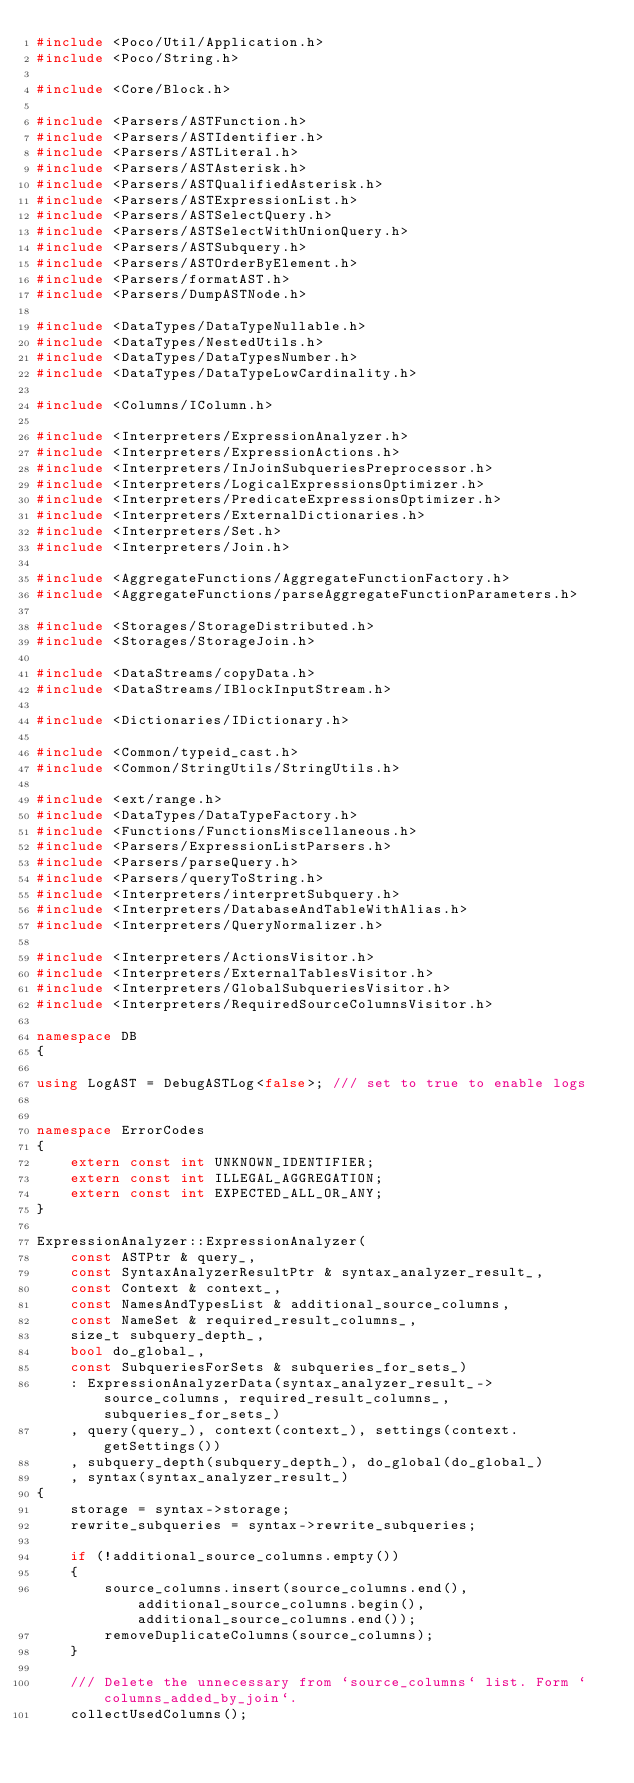<code> <loc_0><loc_0><loc_500><loc_500><_C++_>#include <Poco/Util/Application.h>
#include <Poco/String.h>

#include <Core/Block.h>

#include <Parsers/ASTFunction.h>
#include <Parsers/ASTIdentifier.h>
#include <Parsers/ASTLiteral.h>
#include <Parsers/ASTAsterisk.h>
#include <Parsers/ASTQualifiedAsterisk.h>
#include <Parsers/ASTExpressionList.h>
#include <Parsers/ASTSelectQuery.h>
#include <Parsers/ASTSelectWithUnionQuery.h>
#include <Parsers/ASTSubquery.h>
#include <Parsers/ASTOrderByElement.h>
#include <Parsers/formatAST.h>
#include <Parsers/DumpASTNode.h>

#include <DataTypes/DataTypeNullable.h>
#include <DataTypes/NestedUtils.h>
#include <DataTypes/DataTypesNumber.h>
#include <DataTypes/DataTypeLowCardinality.h>

#include <Columns/IColumn.h>

#include <Interpreters/ExpressionAnalyzer.h>
#include <Interpreters/ExpressionActions.h>
#include <Interpreters/InJoinSubqueriesPreprocessor.h>
#include <Interpreters/LogicalExpressionsOptimizer.h>
#include <Interpreters/PredicateExpressionsOptimizer.h>
#include <Interpreters/ExternalDictionaries.h>
#include <Interpreters/Set.h>
#include <Interpreters/Join.h>

#include <AggregateFunctions/AggregateFunctionFactory.h>
#include <AggregateFunctions/parseAggregateFunctionParameters.h>

#include <Storages/StorageDistributed.h>
#include <Storages/StorageJoin.h>

#include <DataStreams/copyData.h>
#include <DataStreams/IBlockInputStream.h>

#include <Dictionaries/IDictionary.h>

#include <Common/typeid_cast.h>
#include <Common/StringUtils/StringUtils.h>

#include <ext/range.h>
#include <DataTypes/DataTypeFactory.h>
#include <Functions/FunctionsMiscellaneous.h>
#include <Parsers/ExpressionListParsers.h>
#include <Parsers/parseQuery.h>
#include <Parsers/queryToString.h>
#include <Interpreters/interpretSubquery.h>
#include <Interpreters/DatabaseAndTableWithAlias.h>
#include <Interpreters/QueryNormalizer.h>

#include <Interpreters/ActionsVisitor.h>
#include <Interpreters/ExternalTablesVisitor.h>
#include <Interpreters/GlobalSubqueriesVisitor.h>
#include <Interpreters/RequiredSourceColumnsVisitor.h>

namespace DB
{

using LogAST = DebugASTLog<false>; /// set to true to enable logs


namespace ErrorCodes
{
    extern const int UNKNOWN_IDENTIFIER;
    extern const int ILLEGAL_AGGREGATION;
    extern const int EXPECTED_ALL_OR_ANY;
}

ExpressionAnalyzer::ExpressionAnalyzer(
    const ASTPtr & query_,
    const SyntaxAnalyzerResultPtr & syntax_analyzer_result_,
    const Context & context_,
    const NamesAndTypesList & additional_source_columns,
    const NameSet & required_result_columns_,
    size_t subquery_depth_,
    bool do_global_,
    const SubqueriesForSets & subqueries_for_sets_)
    : ExpressionAnalyzerData(syntax_analyzer_result_->source_columns, required_result_columns_, subqueries_for_sets_)
    , query(query_), context(context_), settings(context.getSettings())
    , subquery_depth(subquery_depth_), do_global(do_global_)
    , syntax(syntax_analyzer_result_)
{
    storage = syntax->storage;
    rewrite_subqueries = syntax->rewrite_subqueries;

    if (!additional_source_columns.empty())
    {
        source_columns.insert(source_columns.end(), additional_source_columns.begin(), additional_source_columns.end());
        removeDuplicateColumns(source_columns);
    }

    /// Delete the unnecessary from `source_columns` list. Form `columns_added_by_join`.
    collectUsedColumns();
</code> 